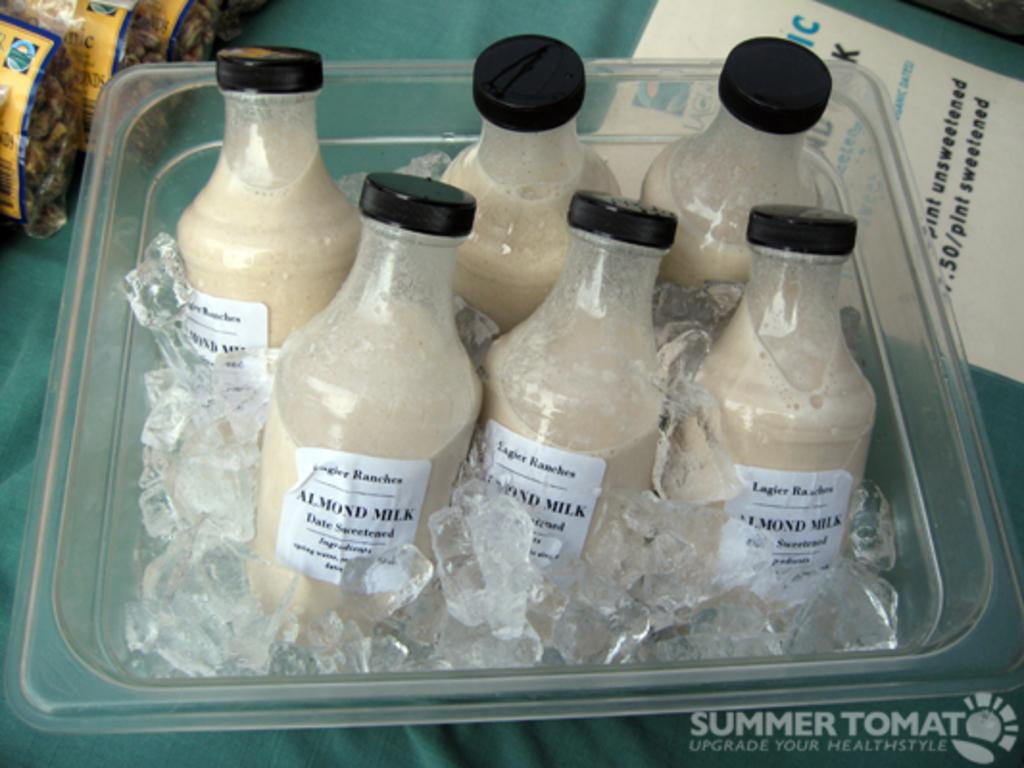<image>
Relay a brief, clear account of the picture shown. Six bottles of Almond milk are in a plastic container which is full of ice. 